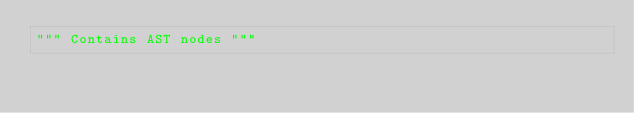Convert code to text. <code><loc_0><loc_0><loc_500><loc_500><_Python_>""" Contains AST nodes """
</code> 